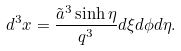<formula> <loc_0><loc_0><loc_500><loc_500>d ^ { 3 } x = \frac { \tilde { a } ^ { 3 } \sinh \eta } { q ^ { 3 } } d \xi d \phi d \eta .</formula> 